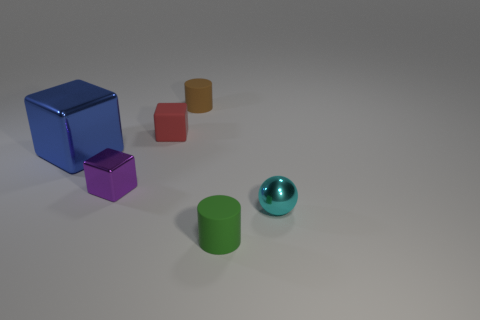Is there anything else that is the same size as the blue shiny block?
Make the answer very short. No. There is a large metallic object; are there any blue things to the right of it?
Offer a terse response. No. There is a cylinder that is in front of the brown thing; are there any brown cylinders that are right of it?
Ensure brevity in your answer.  No. Are there the same number of blocks right of the brown matte cylinder and purple blocks on the left side of the tiny sphere?
Your answer should be compact. No. The small cube that is made of the same material as the small ball is what color?
Offer a terse response. Purple. Are there any cylinders that have the same material as the small cyan thing?
Your answer should be very brief. No. How many objects are large cubes or small red matte things?
Your answer should be very brief. 2. Does the red block have the same material as the block in front of the large blue object?
Keep it short and to the point. No. What is the size of the cylinder behind the tiny purple cube?
Give a very brief answer. Small. Is the number of balls less than the number of large brown cylinders?
Keep it short and to the point. No. 